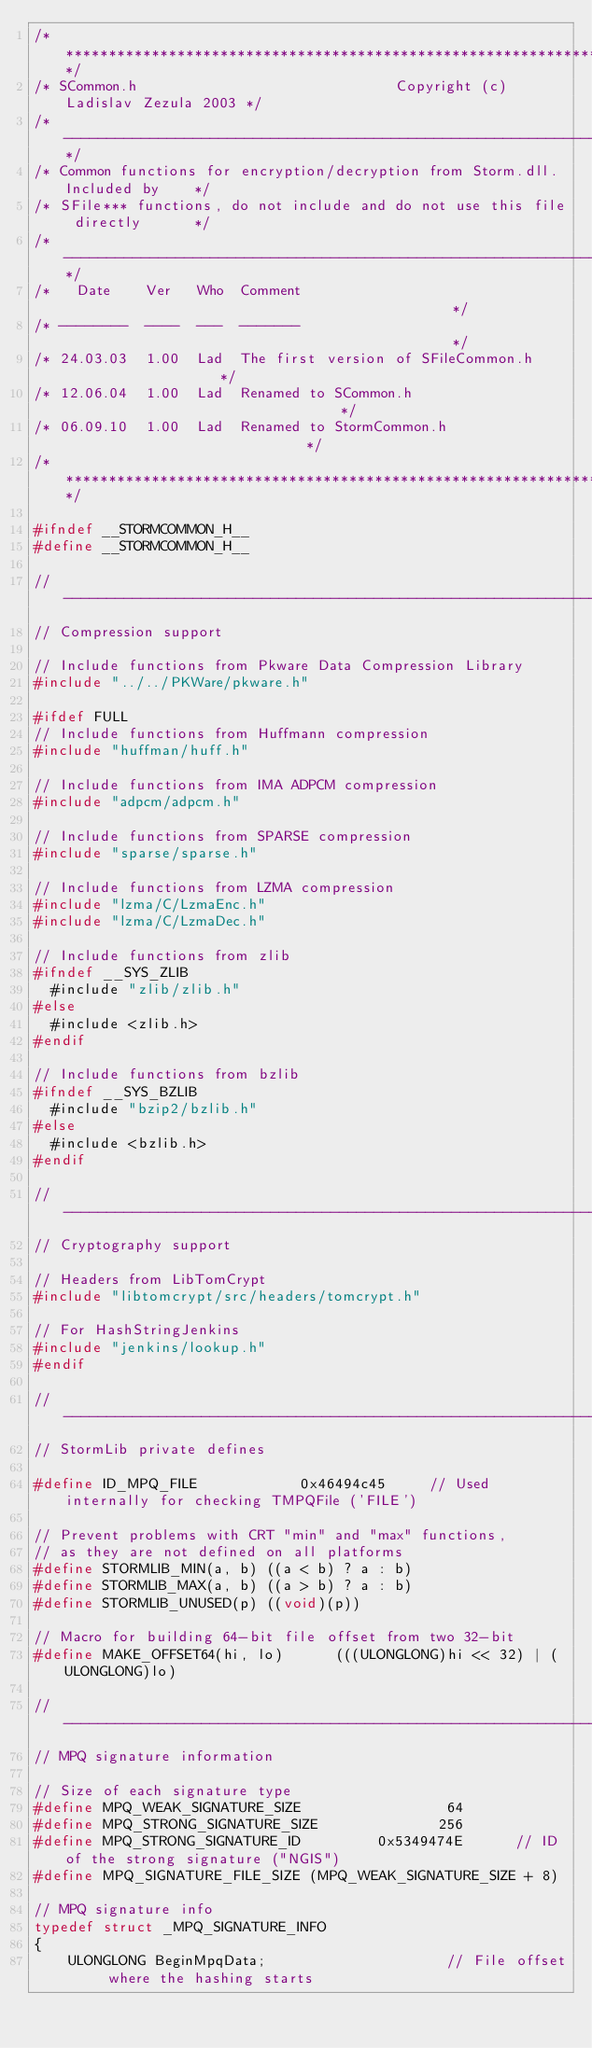Convert code to text. <code><loc_0><loc_0><loc_500><loc_500><_C_>/*****************************************************************************/
/* SCommon.h                              Copyright (c) Ladislav Zezula 2003 */
/*---------------------------------------------------------------------------*/
/* Common functions for encryption/decryption from Storm.dll. Included by    */
/* SFile*** functions, do not include and do not use this file directly      */
/*---------------------------------------------------------------------------*/
/*   Date    Ver   Who  Comment                                              */
/* --------  ----  ---  -------                                              */
/* 24.03.03  1.00  Lad  The first version of SFileCommon.h                   */
/* 12.06.04  1.00  Lad  Renamed to SCommon.h                                 */
/* 06.09.10  1.00  Lad  Renamed to StormCommon.h                             */
/*****************************************************************************/

#ifndef __STORMCOMMON_H__
#define __STORMCOMMON_H__

//-----------------------------------------------------------------------------
// Compression support

// Include functions from Pkware Data Compression Library
#include "../../PKWare/pkware.h"

#ifdef FULL
// Include functions from Huffmann compression
#include "huffman/huff.h"

// Include functions from IMA ADPCM compression
#include "adpcm/adpcm.h"

// Include functions from SPARSE compression
#include "sparse/sparse.h"

// Include functions from LZMA compression
#include "lzma/C/LzmaEnc.h"
#include "lzma/C/LzmaDec.h"

// Include functions from zlib
#ifndef __SYS_ZLIB
  #include "zlib/zlib.h"
#else
  #include <zlib.h>
#endif

// Include functions from bzlib
#ifndef __SYS_BZLIB
  #include "bzip2/bzlib.h"
#else
  #include <bzlib.h>
#endif

//-----------------------------------------------------------------------------
// Cryptography support

// Headers from LibTomCrypt
#include "libtomcrypt/src/headers/tomcrypt.h"

// For HashStringJenkins
#include "jenkins/lookup.h"
#endif

//-----------------------------------------------------------------------------
// StormLib private defines

#define ID_MPQ_FILE            0x46494c45     // Used internally for checking TMPQFile ('FILE')

// Prevent problems with CRT "min" and "max" functions,
// as they are not defined on all platforms
#define STORMLIB_MIN(a, b) ((a < b) ? a : b)
#define STORMLIB_MAX(a, b) ((a > b) ? a : b)
#define STORMLIB_UNUSED(p) ((void)(p))

// Macro for building 64-bit file offset from two 32-bit
#define MAKE_OFFSET64(hi, lo)      (((ULONGLONG)hi << 32) | (ULONGLONG)lo)

//-----------------------------------------------------------------------------
// MPQ signature information

// Size of each signature type
#define MPQ_WEAK_SIGNATURE_SIZE                 64
#define MPQ_STRONG_SIGNATURE_SIZE              256
#define MPQ_STRONG_SIGNATURE_ID         0x5349474E      // ID of the strong signature ("NGIS")
#define MPQ_SIGNATURE_FILE_SIZE (MPQ_WEAK_SIGNATURE_SIZE + 8)

// MPQ signature info
typedef struct _MPQ_SIGNATURE_INFO
{
    ULONGLONG BeginMpqData;                     // File offset where the hashing starts</code> 